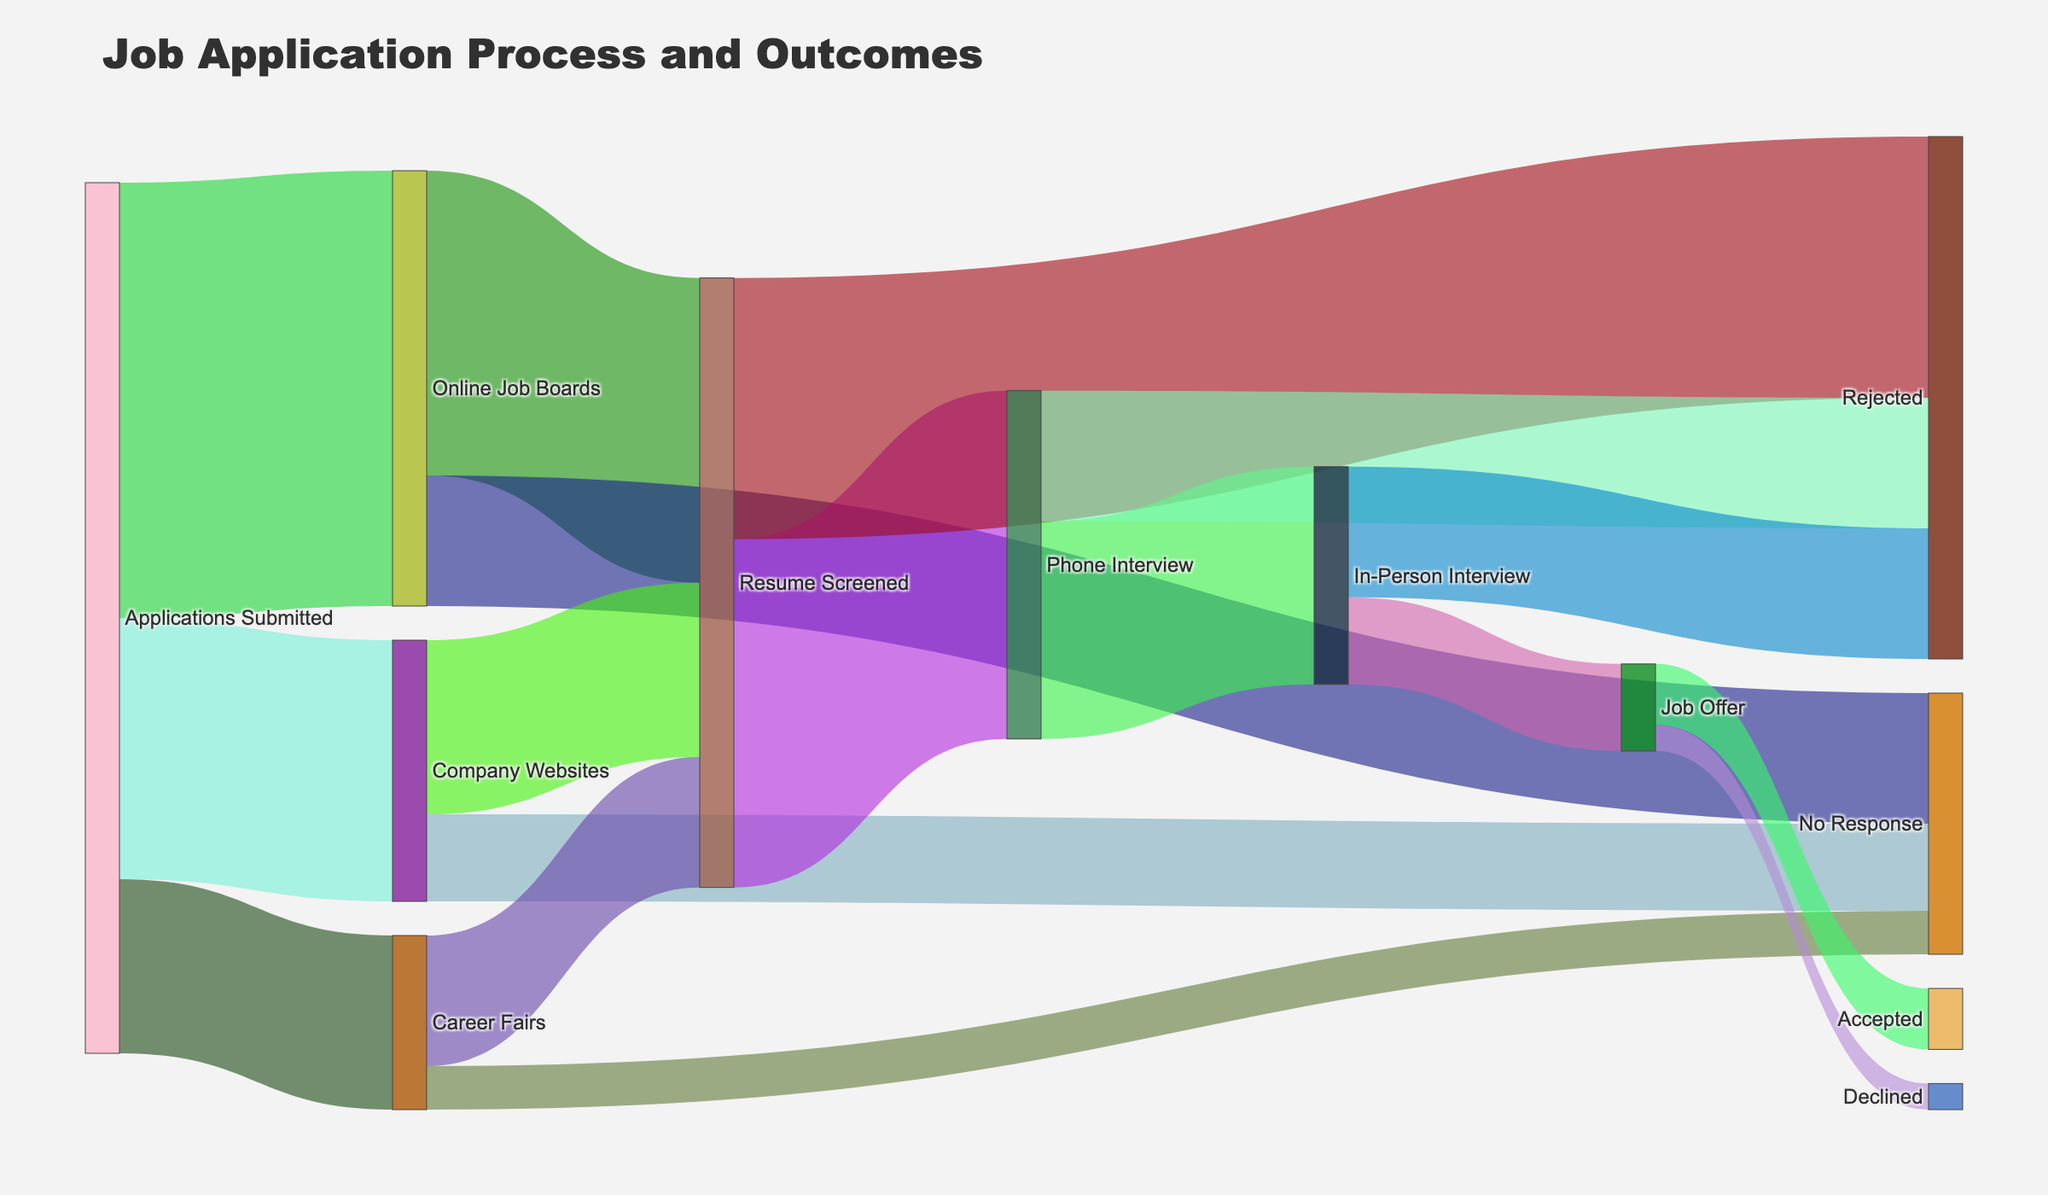How many job applications were submitted through online job boards? According to the figure, the flow from "Applications Submitted" to "Online Job Boards" is labeled with a value of 50.
Answer: 50 Which stage has the highest number of rejected applications? The stage with the highest number of rejected applications is "In-Person Interview" with 15 rejections, as visualized by the flow labeled "Rejected" from "In-Person Interview."
Answer: In-Person Interview What is the total number of job applications that reached the resume screening stage? To find the total number of job applications that reached the resume screening stage, we sum the values from "Online Job Boards," "Company Websites," and "Career Fairs" to "Resume Screened": 35 + 20 + 15 = 70.
Answer: 70 Out of the applications that led to phone interviews, how many eventually resulted in in-person interviews? The flow from "Phone Interview" to "In-Person Interview" in the figure shows a value of 25, representing the number of applications that led to in-person interviews from phone interviews.
Answer: 25 How many job offers were declined? According to the figure, the flow from "Job Offer" to "Declined" is labeled with a value of 3.
Answer: 3 What percentage of phone interviews resulted in job offers? First, find the number of phone interviews that resulted in job offers: 10. The total number of phone interviews is the sum of interviews leading to both offers and rejections: 10 + 15 = 25. The percentage is (10/25) * 100 = 40%.
Answer: 40% Compare the number of job applications that were rejected after the resume screening with the number of those who didn't get any response from company websites. Which is higher? The number of applications rejected after the resume screening is 30, while the number of applications that didn't get a response from company websites is 10. Hence, 30 (rejections) > 10 (no response).
Answer: Rejected after resume screening How many job applications were either declined or accepted? The sum of the applications that were declined and accepted is given by the flows from "Job Offer" to "Declined" and "Accepted": 3 + 7 = 10.
Answer: 10 What proportion of the applications submitted through career fairs received no response? The number of applications submitted through career fairs is 20. Out of these, 5 received no response. The proportion is 5/20 = 25%.
Answer: 25% What is the total number of applications that did not receive a response at any stage of the process? Sum the values of flows marked "No Response" from different stages: Online Job Boards (15) + Company Websites (10) + Career Fairs (5) = 15 + 10 + 5 = 30.
Answer: 30 